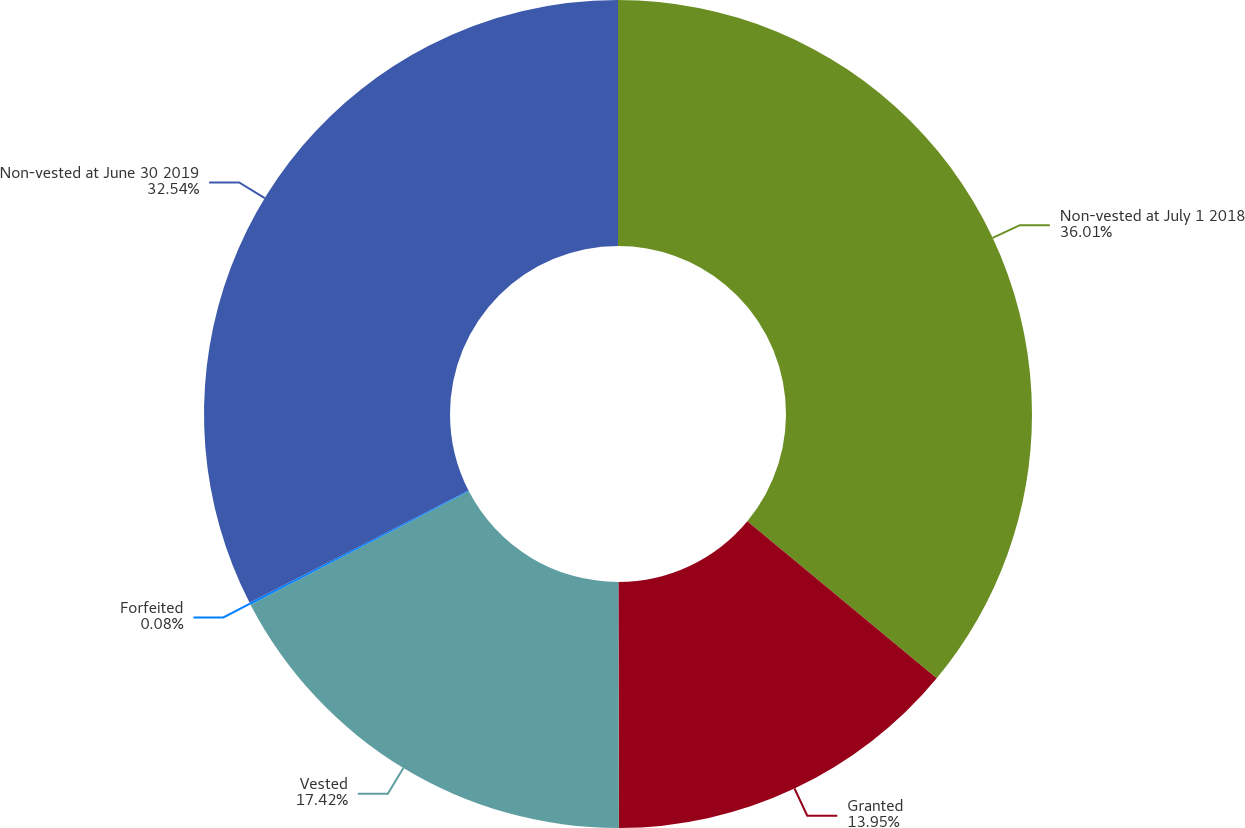Convert chart to OTSL. <chart><loc_0><loc_0><loc_500><loc_500><pie_chart><fcel>Non-vested at July 1 2018<fcel>Granted<fcel>Vested<fcel>Forfeited<fcel>Non-vested at June 30 2019<nl><fcel>36.02%<fcel>13.95%<fcel>17.42%<fcel>0.08%<fcel>32.54%<nl></chart> 